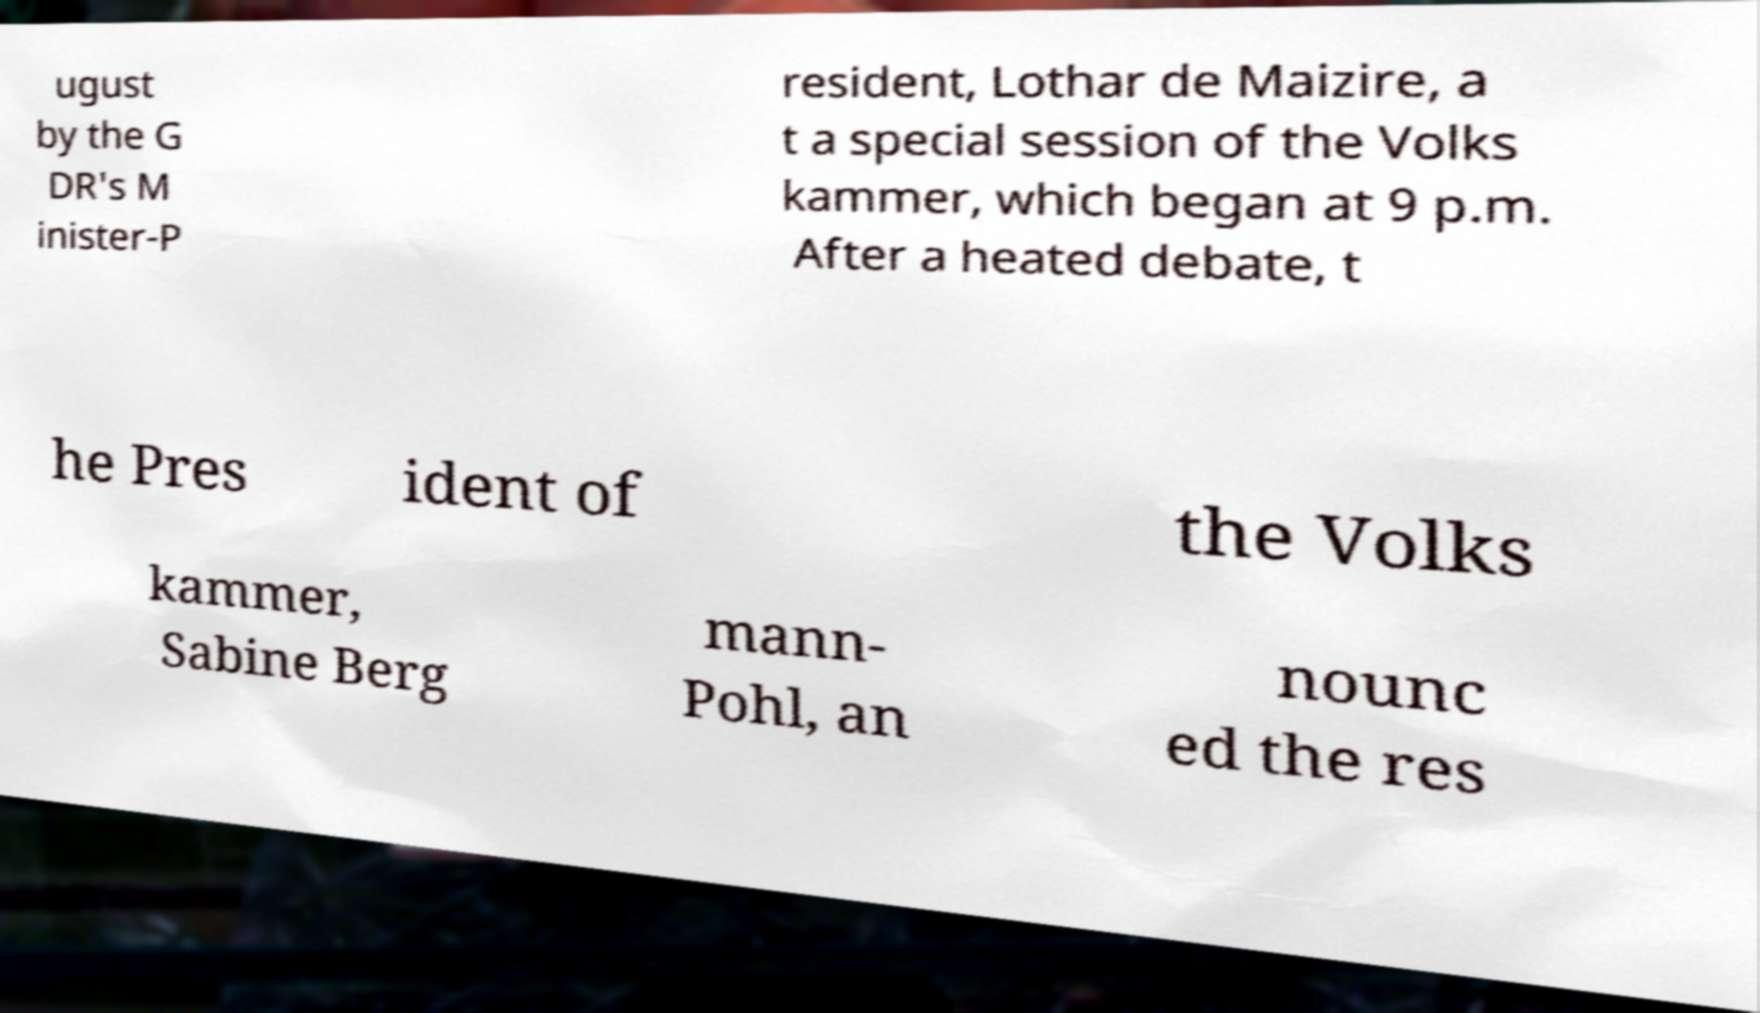Please read and relay the text visible in this image. What does it say? ugust by the G DR's M inister-P resident, Lothar de Maizire, a t a special session of the Volks kammer, which began at 9 p.m. After a heated debate, t he Pres ident of the Volks kammer, Sabine Berg mann- Pohl, an nounc ed the res 